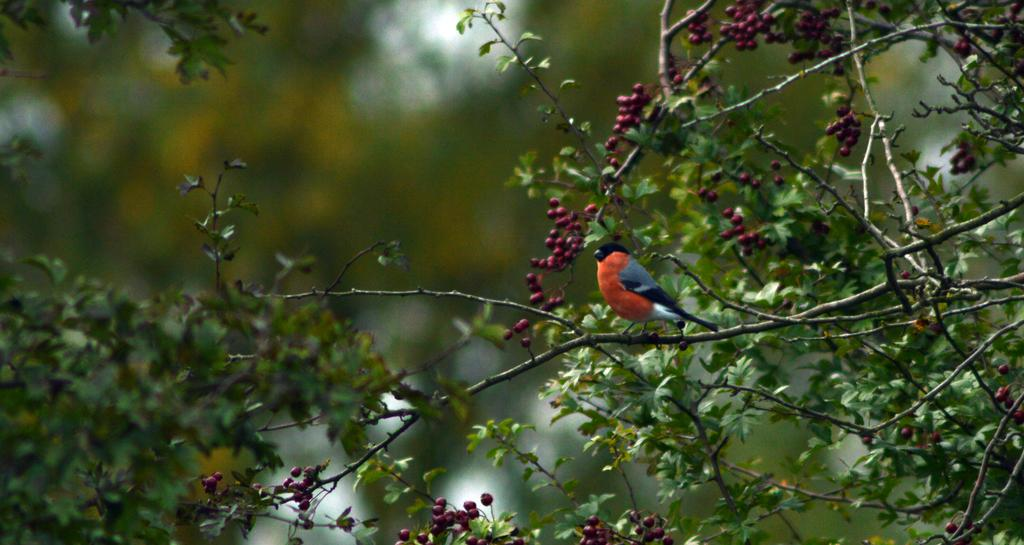What type of animal can be seen in the image? There is a bird in the image. Where is the bird located? The bird is on a tree. What color are the fruits in the image? The fruits in the image are red. Can you describe the background of the image? The background of the image is blurred. Is there an army of kickers in the image? No, there is no army or kickers present in the image. 